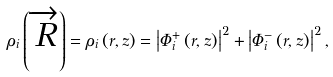<formula> <loc_0><loc_0><loc_500><loc_500>\rho _ { i } \left ( \overrightarrow { R } \right ) = \rho _ { i } \left ( r , z \right ) = \left | \Phi _ { i } ^ { + } \left ( r , z \right ) \right | ^ { 2 } + \left | \Phi _ { i } ^ { - } \left ( r , z \right ) \right | ^ { 2 } ,</formula> 